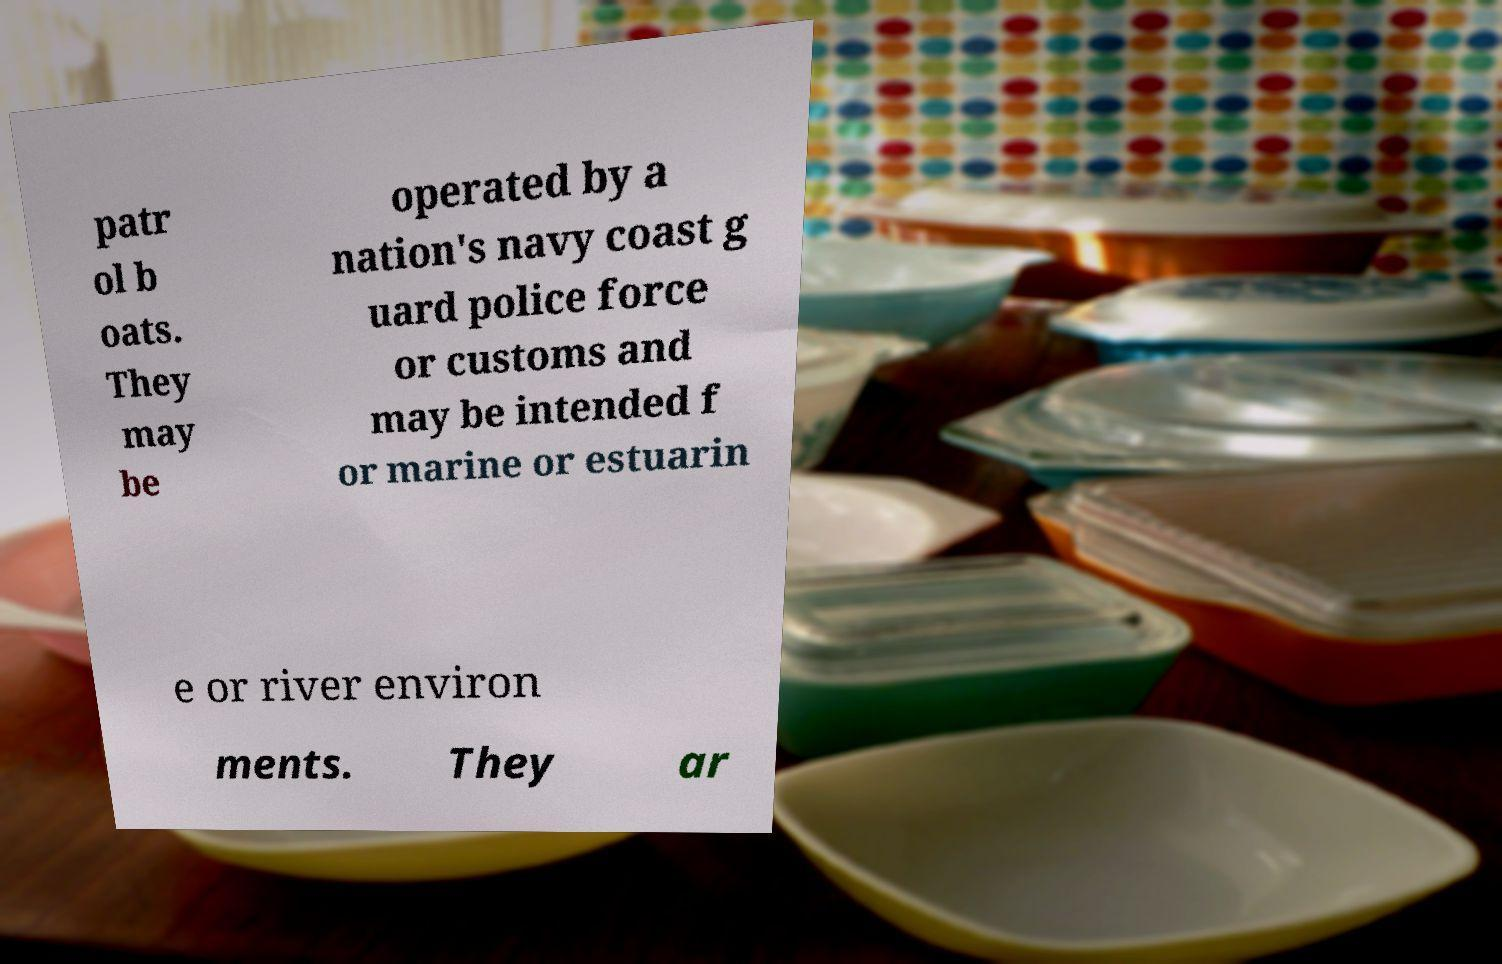Could you assist in decoding the text presented in this image and type it out clearly? patr ol b oats. They may be operated by a nation's navy coast g uard police force or customs and may be intended f or marine or estuarin e or river environ ments. They ar 